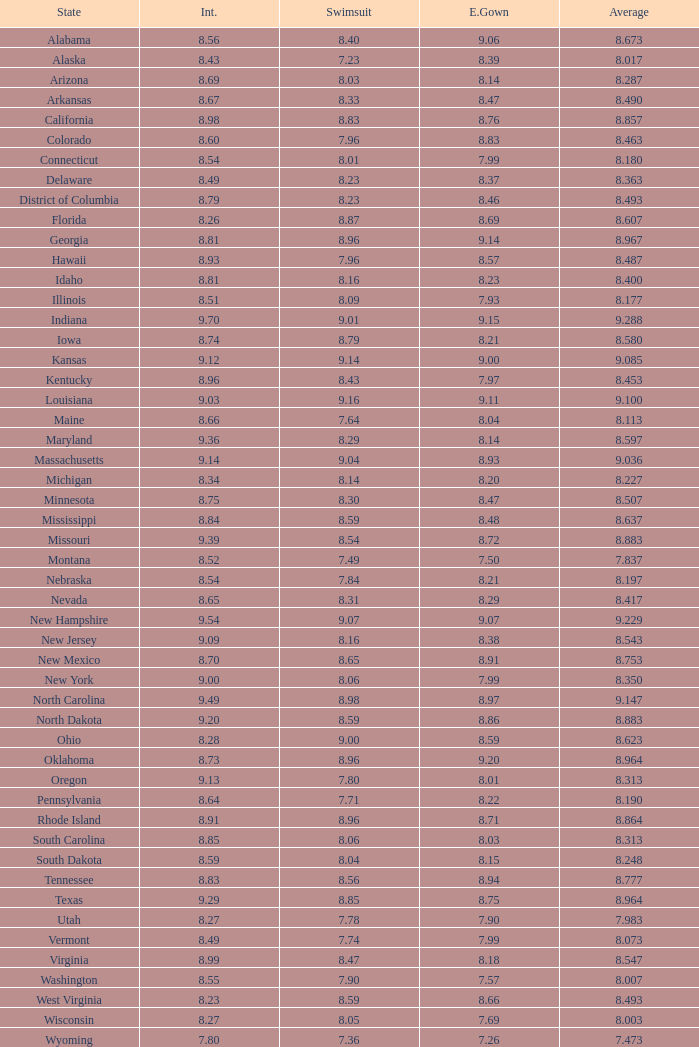Tell me the sum of interview for evening gown more than 8.37 and average of 8.363 None. 